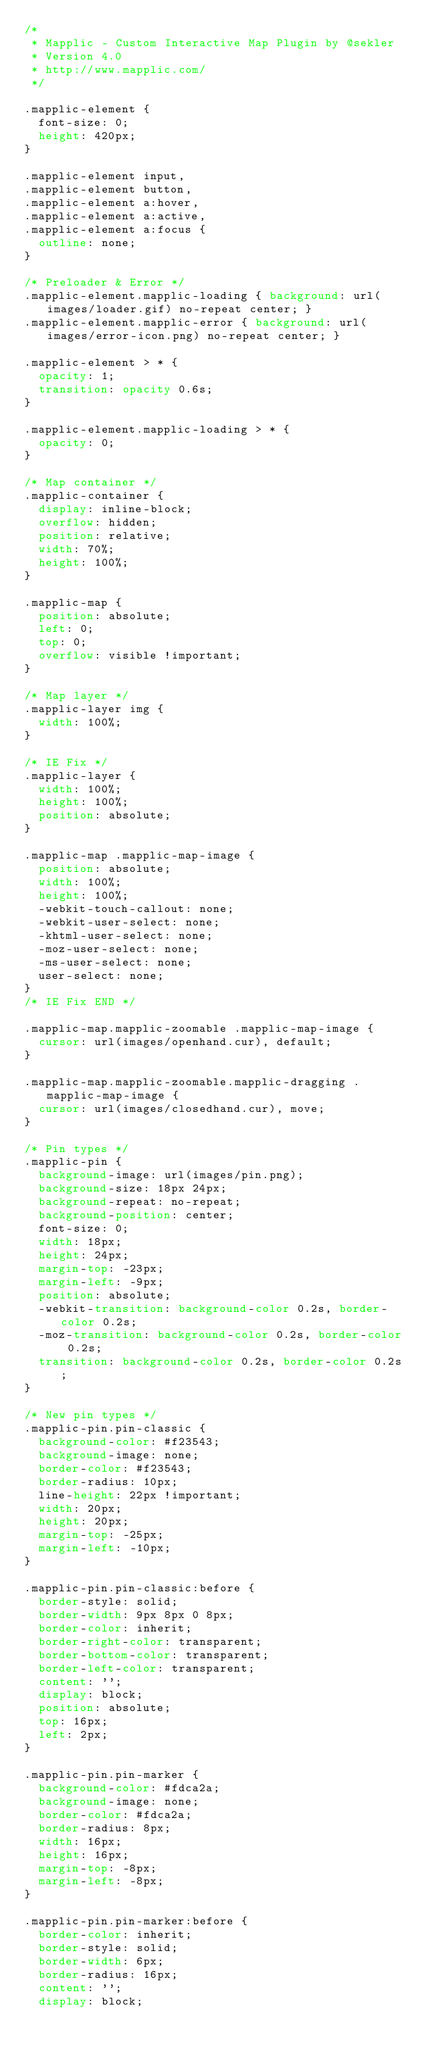<code> <loc_0><loc_0><loc_500><loc_500><_CSS_>/*
 * Mapplic - Custom Interactive Map Plugin by @sekler
 * Version 4.0
 * http://www.mapplic.com/
 */

.mapplic-element {
	font-size: 0;
	height: 420px;
}

.mapplic-element input,
.mapplic-element button,
.mapplic-element a:hover,
.mapplic-element a:active,
.mapplic-element a:focus {
	outline: none;
}

/* Preloader & Error */
.mapplic-element.mapplic-loading { background: url(images/loader.gif) no-repeat center; }
.mapplic-element.mapplic-error { background: url(images/error-icon.png) no-repeat center; }

.mapplic-element > * {
	opacity: 1;
	transition: opacity 0.6s;
}

.mapplic-element.mapplic-loading > * {
	opacity: 0;
}

/* Map container */
.mapplic-container {
	display: inline-block;
	overflow: hidden;
	position: relative;
	width: 70%;
	height: 100%;
}

.mapplic-map {
	position: absolute;
	left: 0;
	top: 0;
	overflow: visible !important;
}

/* Map layer */
.mapplic-layer img {
	width: 100%;
}

/* IE Fix */
.mapplic-layer {
	width: 100%;
	height: 100%;
	position: absolute;
}

.mapplic-map .mapplic-map-image {
	position: absolute;
	width: 100%;
	height: 100%;
	-webkit-touch-callout: none;
	-webkit-user-select: none;
	-khtml-user-select: none;
	-moz-user-select: none;
	-ms-user-select: none;
	user-select: none;
}
/* IE Fix END */

.mapplic-map.mapplic-zoomable .mapplic-map-image {
	cursor: url(images/openhand.cur), default;
}

.mapplic-map.mapplic-zoomable.mapplic-dragging .mapplic-map-image {
	cursor: url(images/closedhand.cur), move;
}

/* Pin types */
.mapplic-pin {
	background-image: url(images/pin.png);
	background-size: 18px 24px;
	background-repeat: no-repeat;
	background-position: center;
	font-size: 0;
	width: 18px;
	height: 24px;
	margin-top: -23px;
	margin-left: -9px;
	position: absolute;
	-webkit-transition: background-color 0.2s, border-color 0.2s;
	-moz-transition: background-color 0.2s, border-color 0.2s;
	transition: background-color 0.2s, border-color 0.2s;
}

/* New pin types */
.mapplic-pin.pin-classic {
	background-color: #f23543;
	background-image: none;
	border-color: #f23543;
	border-radius: 10px;
	line-height: 22px !important;
	width: 20px;
	height: 20px;
	margin-top: -25px;
	margin-left: -10px;
}

.mapplic-pin.pin-classic:before {
	border-style: solid;
	border-width: 9px 8px 0 8px;
	border-color: inherit;
	border-right-color: transparent;
	border-bottom-color: transparent;
	border-left-color: transparent;
	content: '';
	display: block;
	position: absolute;
	top: 16px;
	left: 2px;
}

.mapplic-pin.pin-marker {
	background-color: #fdca2a;
	background-image: none;
	border-color: #fdca2a;
	border-radius: 8px;
	width: 16px;
	height: 16px;
	margin-top: -8px;
	margin-left: -8px;
}

.mapplic-pin.pin-marker:before {
	border-color: inherit;
	border-style: solid;
	border-width: 6px;
	border-radius: 16px;
	content: '';
	display: block;</code> 